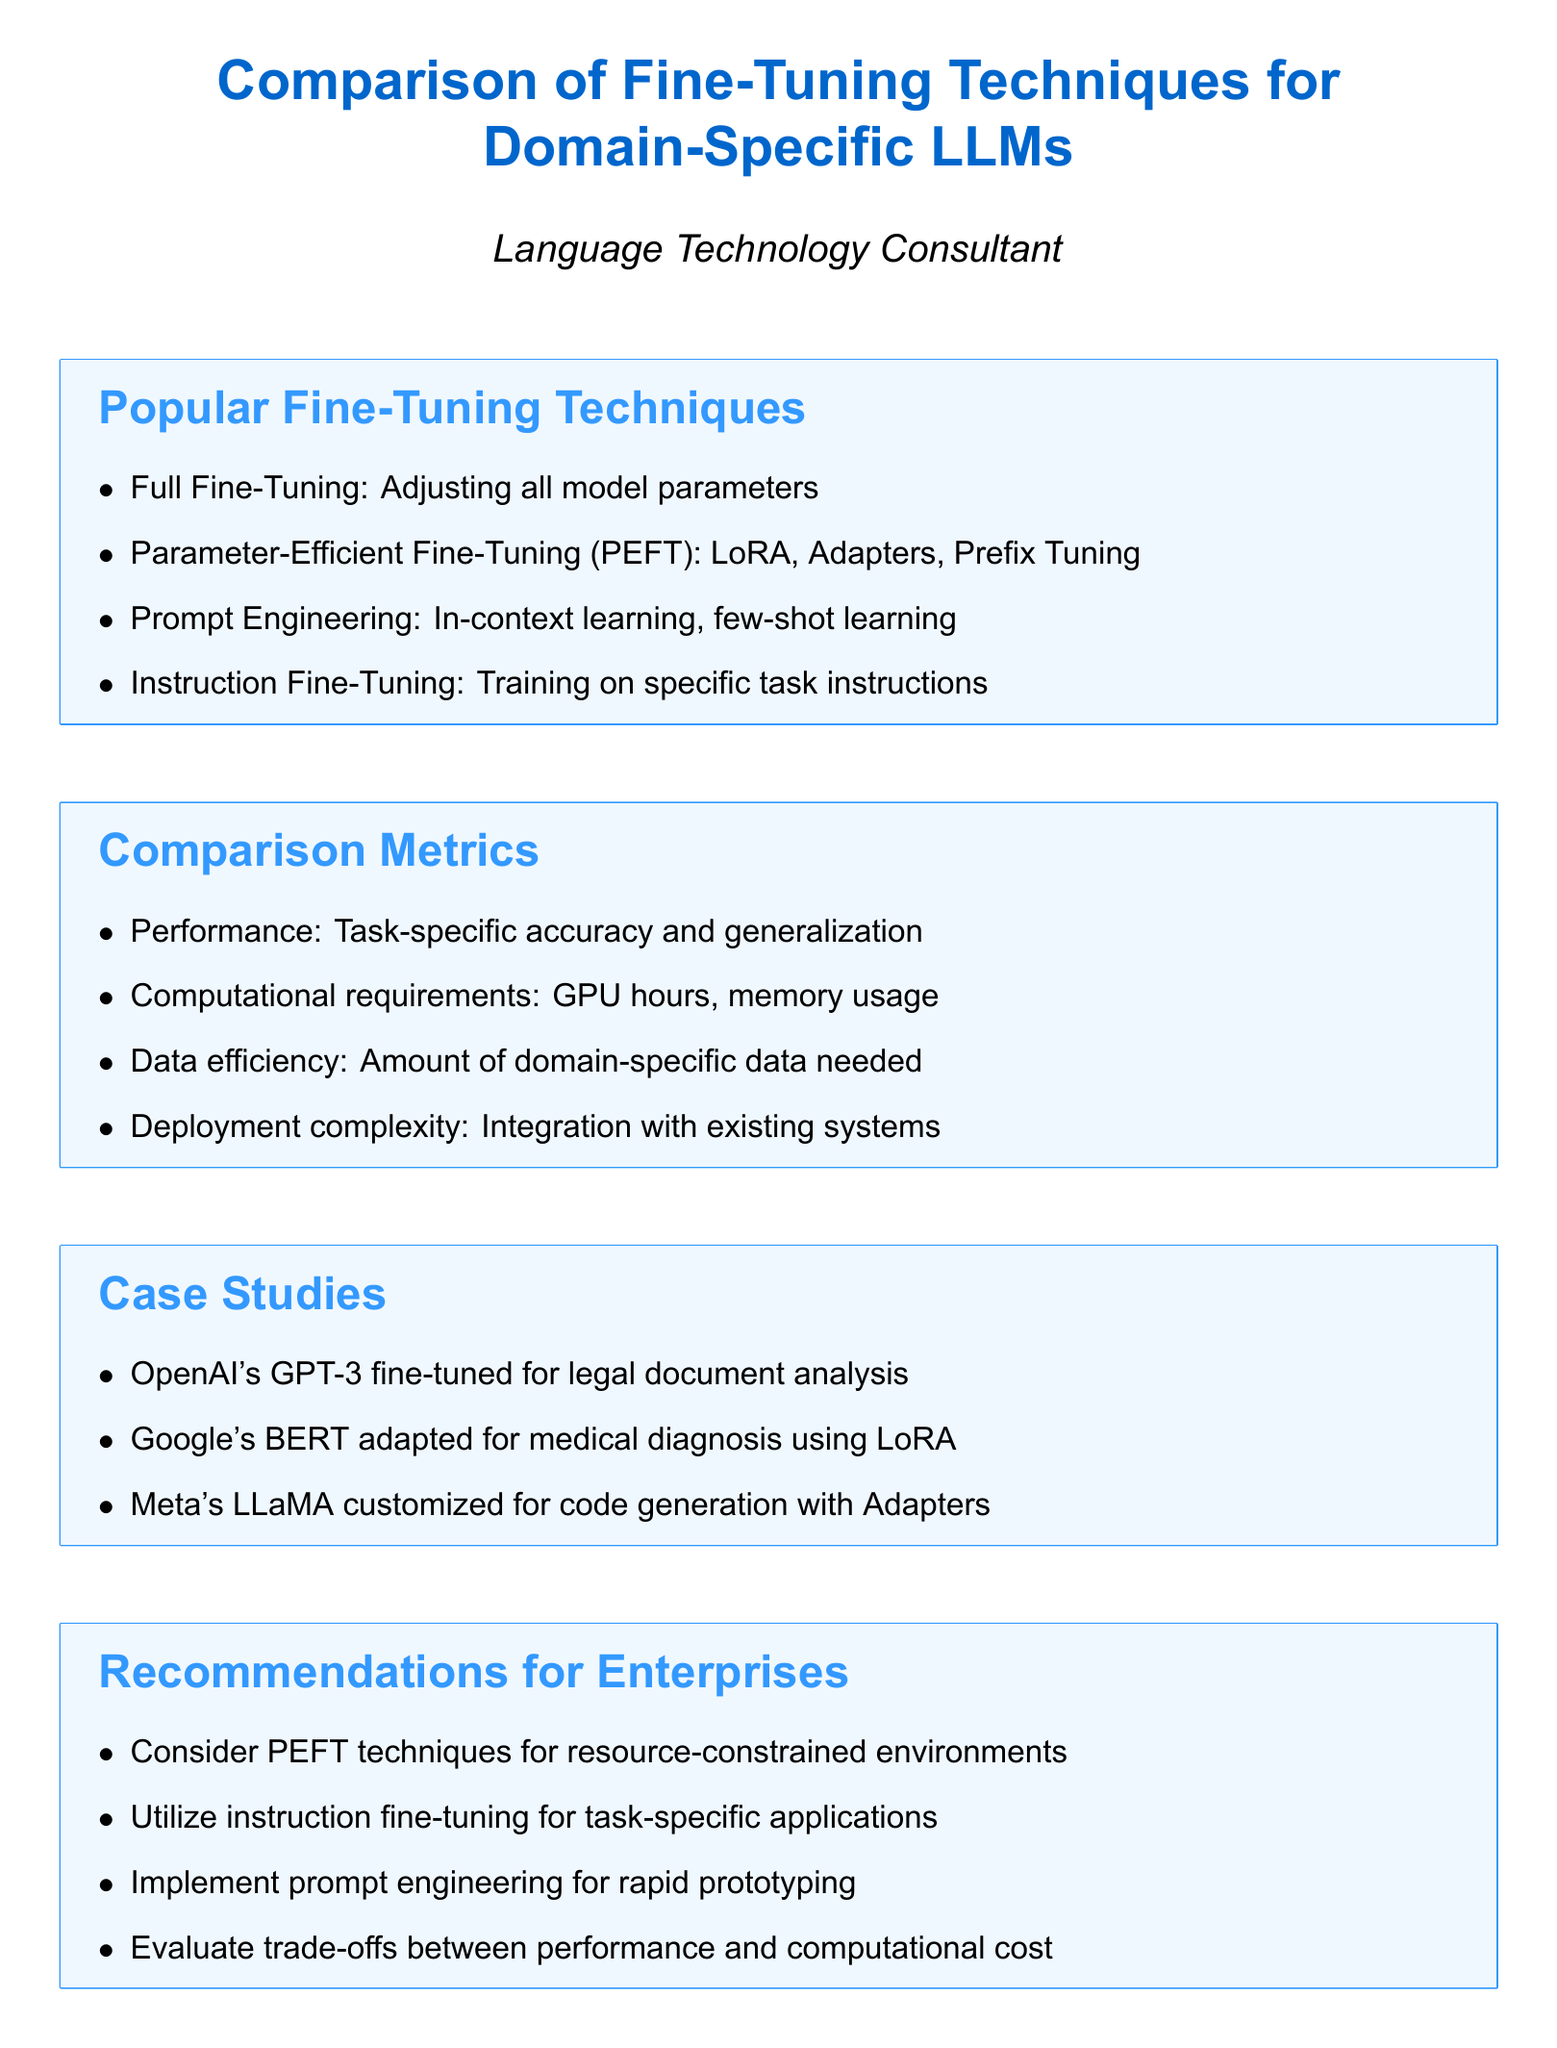What are the popular fine-tuning techniques? The document lists the popular fine-tuning techniques, including full fine-tuning, parameter-efficient fine-tuning, prompt engineering, and instruction fine-tuning.
Answer: Full Fine-Tuning, Parameter-Efficient Fine-Tuning, Prompt Engineering, Instruction Fine-Tuning What is one metric used for comparison? The document outlines several comparison metrics, including performance, computational requirements, and data efficiency.
Answer: Performance Which case study involved GPT-3? The document mentions a case study where OpenAI's GPT-3 was fine-tuned for a specific purpose.
Answer: OpenAI's GPT-3 fine-tuned for legal document analysis What does PEFT stand for? The term PEFT is defined in the document as a type of fine-tuning technique.
Answer: Parameter-Efficient Fine-Tuning Which recommendation is given for resource-constrained environments? The document provides specific recommendations for enterprises, one of which is related to PEFT techniques.
Answer: Consider PEFT techniques for resource-constrained environments What future trend focuses on adaptation methods? The document identifies a future trend that highlights the need for efficiency in adaptation techniques.
Answer: Increased focus on data-efficient adaptation methods What is the main focus of instruction fine-tuning? The document specifies that instruction fine-tuning is focused on training for particular tasks.
Answer: Training on specific task instructions How many case studies are presented? The document outlines the number of relevant case studies provided in the section.
Answer: Three 